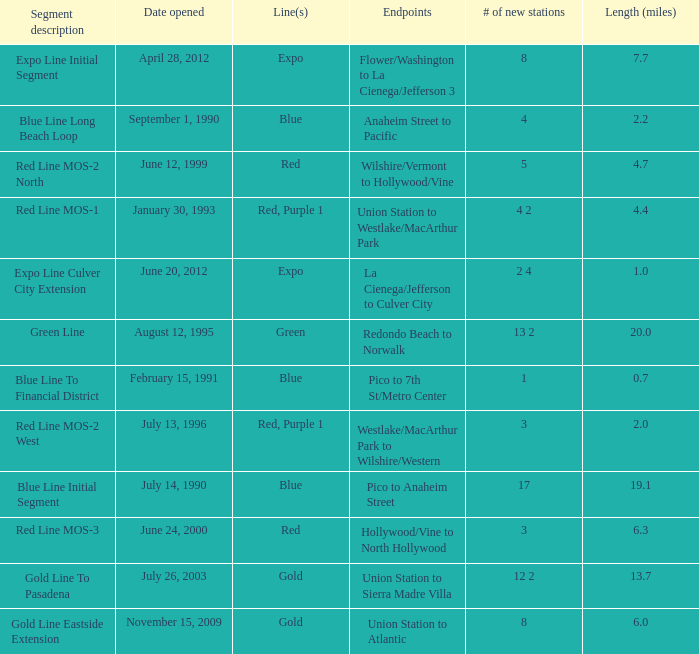How many new stations have a lenght (miles) of 6.0? 1.0. 